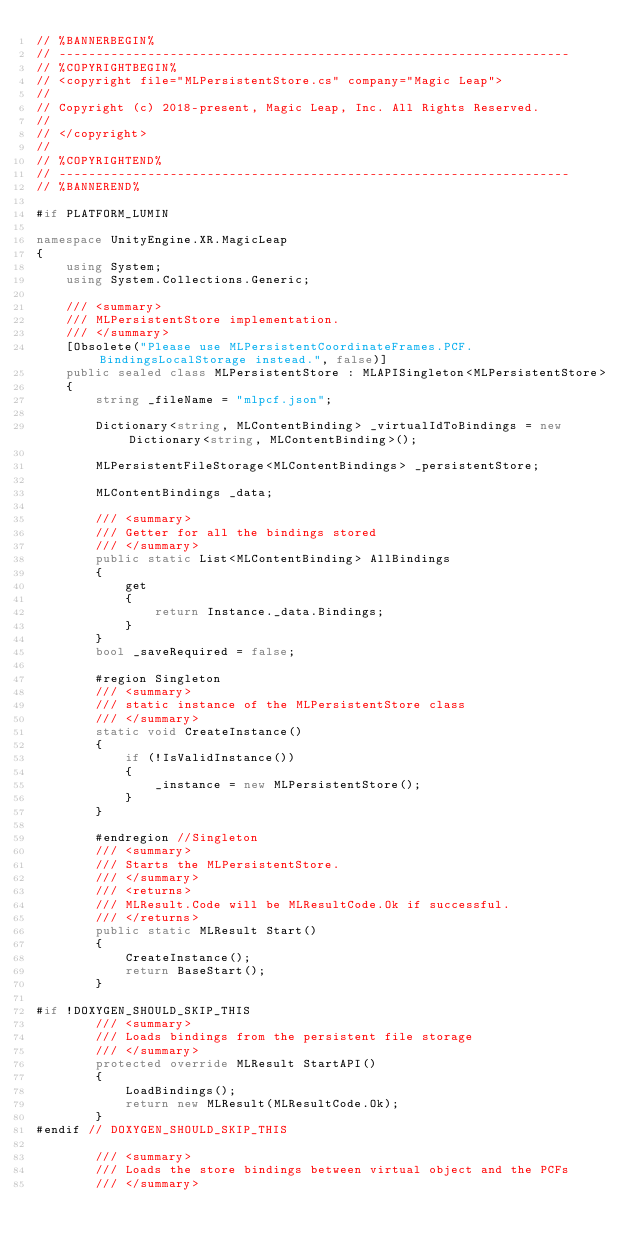<code> <loc_0><loc_0><loc_500><loc_500><_C#_>// %BANNERBEGIN%
// ---------------------------------------------------------------------
// %COPYRIGHTBEGIN%
// <copyright file="MLPersistentStore.cs" company="Magic Leap">
//
// Copyright (c) 2018-present, Magic Leap, Inc. All Rights Reserved.
//
// </copyright>
//
// %COPYRIGHTEND%
// ---------------------------------------------------------------------
// %BANNEREND%

#if PLATFORM_LUMIN

namespace UnityEngine.XR.MagicLeap
{
    using System;
    using System.Collections.Generic;

    /// <summary>
    /// MLPersistentStore implementation.
    /// </summary>
    [Obsolete("Please use MLPersistentCoordinateFrames.PCF.BindingsLocalStorage instead.", false)]
    public sealed class MLPersistentStore : MLAPISingleton<MLPersistentStore>
    {
        string _fileName = "mlpcf.json";

        Dictionary<string, MLContentBinding> _virtualIdToBindings = new Dictionary<string, MLContentBinding>();

        MLPersistentFileStorage<MLContentBindings> _persistentStore;

        MLContentBindings _data;

        /// <summary>
        /// Getter for all the bindings stored
        /// </summary>
        public static List<MLContentBinding> AllBindings
        {
            get
            {
                return Instance._data.Bindings;
            }
        }
        bool _saveRequired = false;

        #region Singleton
        /// <summary>
        /// static instance of the MLPersistentStore class
        /// </summary>
        static void CreateInstance()
        {
            if (!IsValidInstance())
            {
                _instance = new MLPersistentStore();
            }
        }

        #endregion //Singleton
        /// <summary>
        /// Starts the MLPersistentStore.
        /// </summary>
        /// <returns>
        /// MLResult.Code will be MLResultCode.Ok if successful.
        /// </returns>
        public static MLResult Start()
        {
            CreateInstance();
            return BaseStart();
        }

#if !DOXYGEN_SHOULD_SKIP_THIS
        /// <summary>
        /// Loads bindings from the persistent file storage
        /// </summary>
        protected override MLResult StartAPI()
        {
            LoadBindings();
            return new MLResult(MLResultCode.Ok);
        }
#endif // DOXYGEN_SHOULD_SKIP_THIS

        /// <summary>
        /// Loads the store bindings between virtual object and the PCFs
        /// </summary></code> 